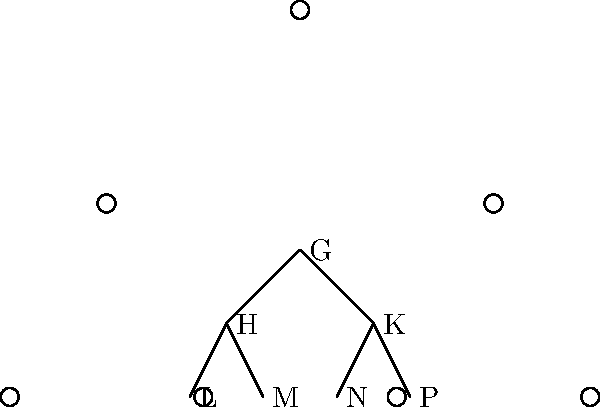As a business owner, you understand the importance of organizational structure. Consider the Hasse diagram above representing a group G and its subgroups. If H and K are maximal subgroups of G, and L, M are subgroups of H, while N, P are subgroups of K, what is the order of G if |L| = 6, |M| = 10, |N| = 15, and |P| = 25? Let's approach this step-by-step, relating it to business organization:

1) In a business, departments (subgroups) often have different sizes, but their combination forms the whole company (group G).

2) We're given that H and K are maximal subgroups of G. This means they're the largest subgroups of G, similar to main divisions in a company.

3) We know the sizes of the smallest subgroups:
   |L| = 6, |M| = 10 (subgroups of H)
   |N| = 15, |P| = 25 (subgroups of K)

4) In group theory, the order of a subgroup must divide the order of the group. So, |H| must be divisible by both 6 and 10.

5) The least common multiple (LCM) of 6 and 10 is 30. So, |H| = 30.

6) Similarly, |K| must be divisible by both 15 and 25. The LCM of 15 and 25 is 75. So, |K| = 75.

7) Now, G contains both H and K. The order of G must be divisible by both |H| and |K|.

8) The LCM of 30 and 75 is 150.

Therefore, the smallest possible order of G is 150.
Answer: 150 